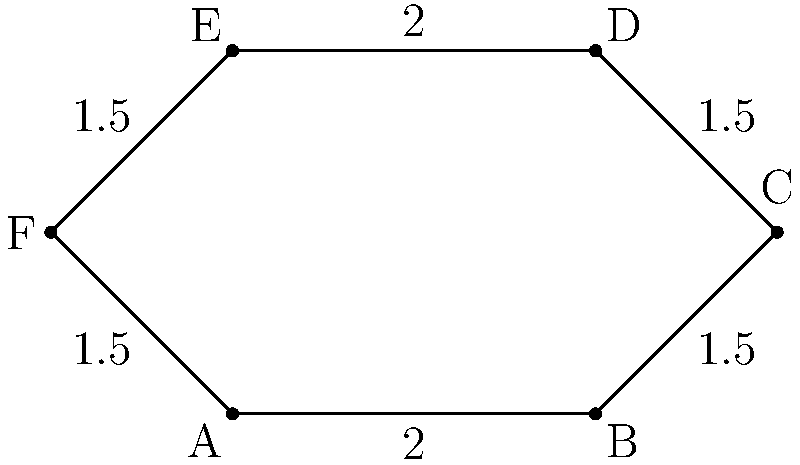Your gaming clan's star-shaped insignia is represented by the hexagram shown above. If all interior angles are $120^\circ$ and the side lengths are as indicated (in centimeters), what is the perimeter of the insignia? To find the perimeter of the star-shaped insignia, we need to sum up all the side lengths:

1. Identify all side lengths:
   - AB = 2 cm
   - BC = 1.5 cm
   - CD = 1.5 cm
   - DE = 2 cm
   - EF = 1.5 cm
   - FA = 1.5 cm

2. Add all side lengths:
   $\text{Perimeter} = 2 + 1.5 + 1.5 + 2 + 1.5 + 1.5$

3. Simplify:
   $\text{Perimeter} = 10$ cm

Therefore, the perimeter of the star-shaped insignia is 10 cm.
Answer: 10 cm 